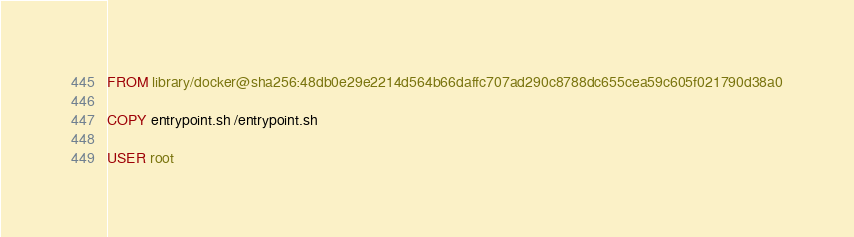Convert code to text. <code><loc_0><loc_0><loc_500><loc_500><_Dockerfile_>FROM library/docker@sha256:48db0e29e2214d564b66daffc707ad290c8788dc655cea59c605f021790d38a0

COPY entrypoint.sh /entrypoint.sh

USER root
</code> 